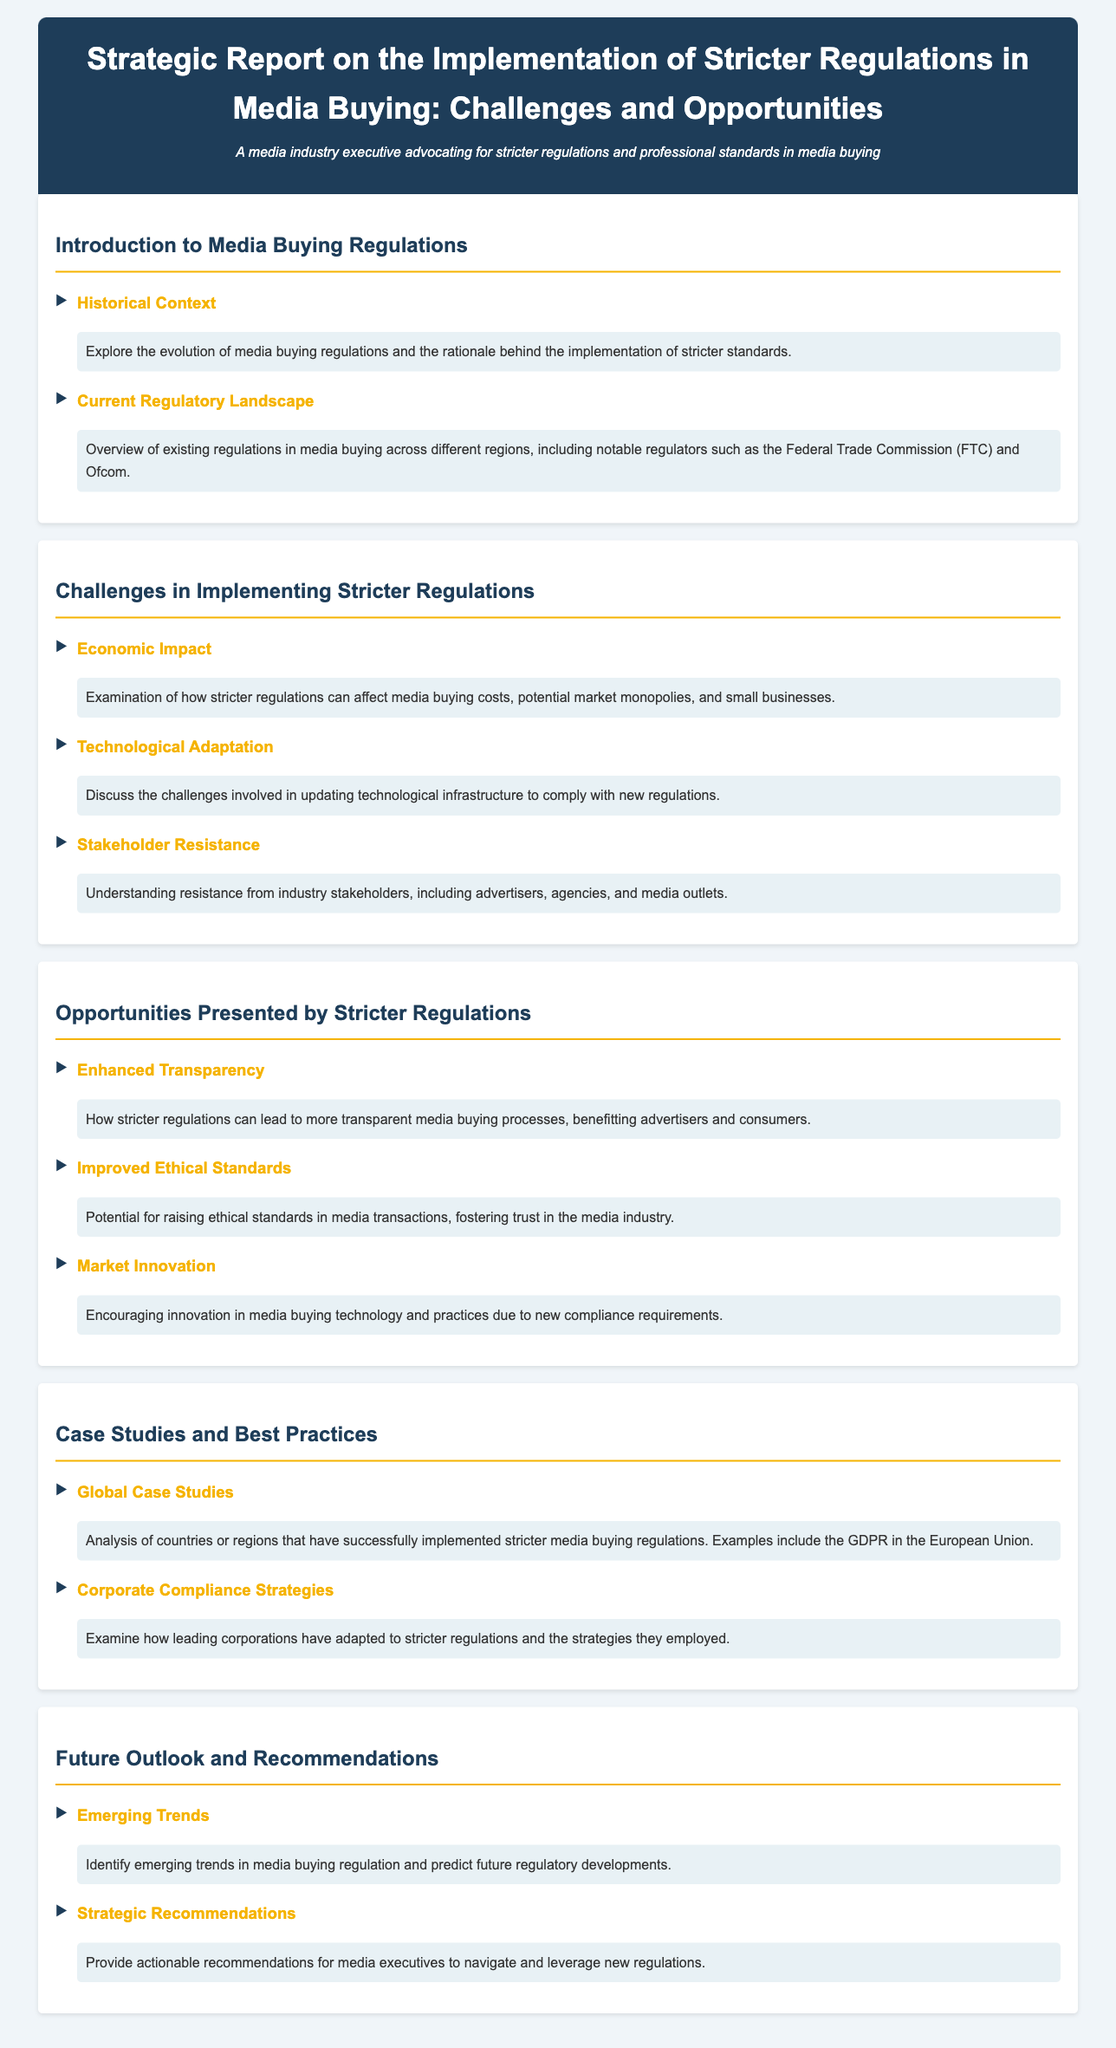What is the title of the report? The title is stated prominently at the top of the document, indicating the focus on media buying regulations.
Answer: Strategic Report on the Implementation of Stricter Regulations in Media Buying: Challenges and Opportunities Who are notable regulators mentioned in the current regulatory landscape? The document lists examples of key regulators involved in media buying regulations.
Answer: Federal Trade Commission (FTC) and Ofcom What is one challenge mentioned regarding economic impact? The document highlights specific concerns regarding the effects of regulations on the market and businesses.
Answer: Potential market monopolies What benefit does enhanced transparency offer according to the document? The document discusses positive outcomes resulting from stricter regulations, particularly regarding media buying processes.
Answer: Benefitting advertisers and consumers Which case study example is provided in the document? The document refers to successful implementations of media buying regulations in various contexts.
Answer: GDPR in the European Union What are the strategic recommendations focused on? The document addresses actionable insights aimed at navigating new regulations and their implications.
Answer: Navigate and leverage new regulations 